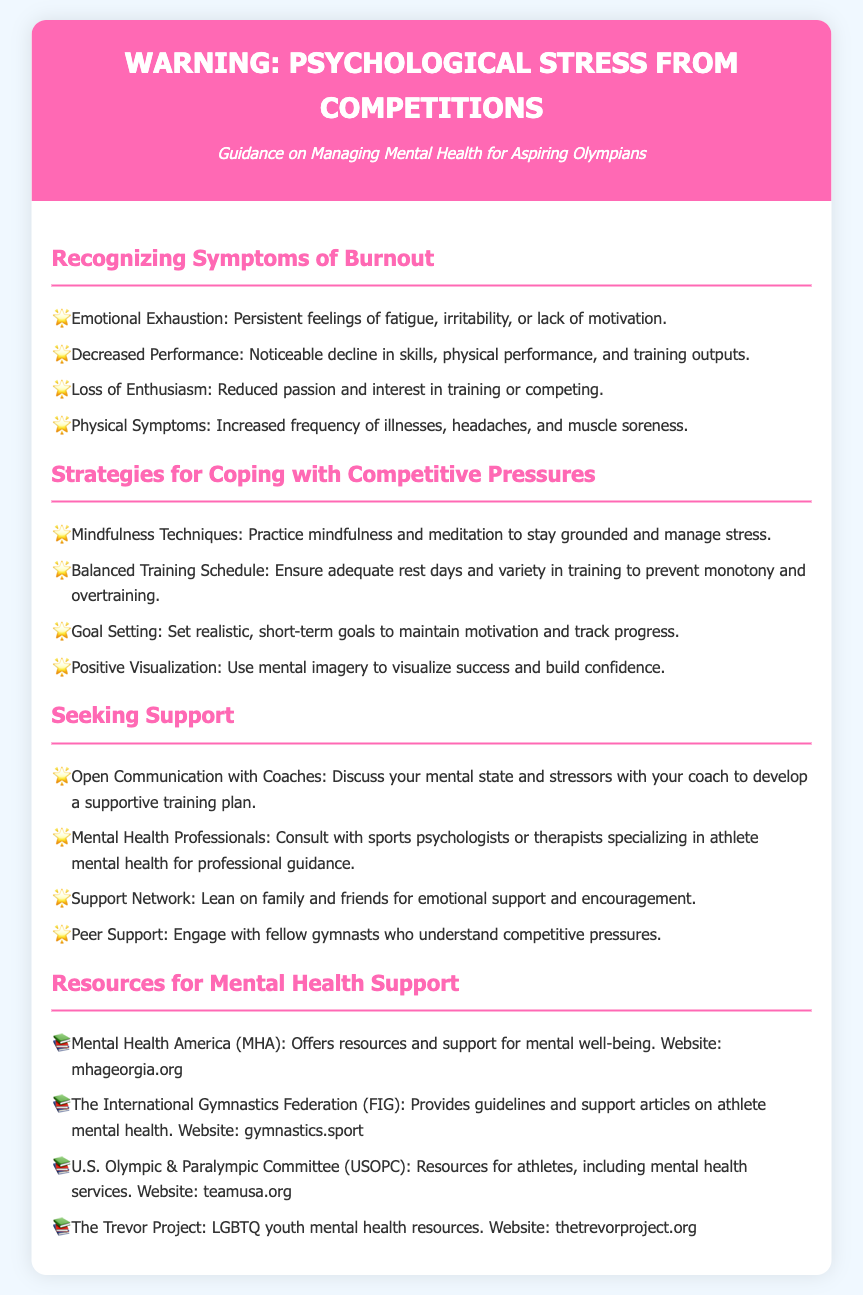What is the title of the document? The title is explicitly stated at the top of the document, which indicates the main subject of the content.
Answer: Warning: Psychological Stress from Competitions What are the symptoms of burnout? The document lists specific symptoms of burnout under the relevant section that describes the characteristics to recognize.
Answer: Emotional Exhaustion, Decreased Performance, Loss of Enthusiasm, Physical Symptoms What technique is suggested for managing stress? The document provides various coping strategies, one of which is specified in the section on coping with competitive pressures.
Answer: Mindfulness Techniques Who should you communicate with about your mental state? The document indicates the importance of discussing mental health with a specific individual or group in the seeking support section.
Answer: Coaches Which organization offers resources for mental well-being? The document lists multiple organizations that provide mental health resources, one of which is mentioned directly.
Answer: Mental Health America What is a recommended strategy for maintaining motivation? A strategy listed in the document focuses on setting specific plans to enhance motivation during training and competition.
Answer: Goal Setting How many resources are listed for mental health support? The document provides a specific number of resources in the section dedicated to mental health support.
Answer: Four What method can be used to visualize success? The document describes a specific mental exercise aimed at building confidence through visualization techniques.
Answer: Positive Visualization What is the subtitle of the document? The subtitle is a descriptive phrase that clarifies the intent of the document and is located right beneath the title.
Answer: Guidance on Managing Mental Health for Aspiring Olympians 